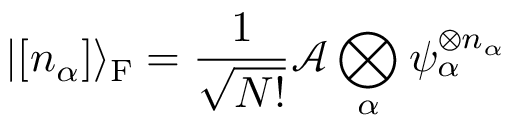<formula> <loc_0><loc_0><loc_500><loc_500>| [ n _ { \alpha } ] \rangle _ { F } = { \frac { 1 } { \sqrt { N ! } } } { \mathcal { A } } \bigotimes _ { \alpha } \psi _ { \alpha } ^ { \otimes n _ { \alpha } }</formula> 